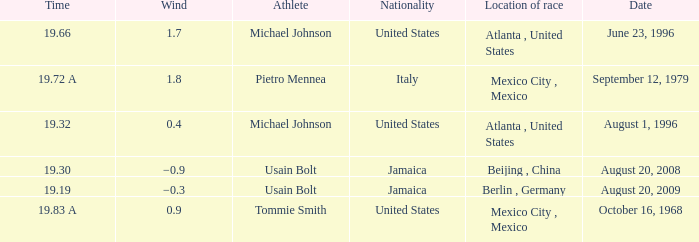What's the wind when the time was 19.32? 0.4. 